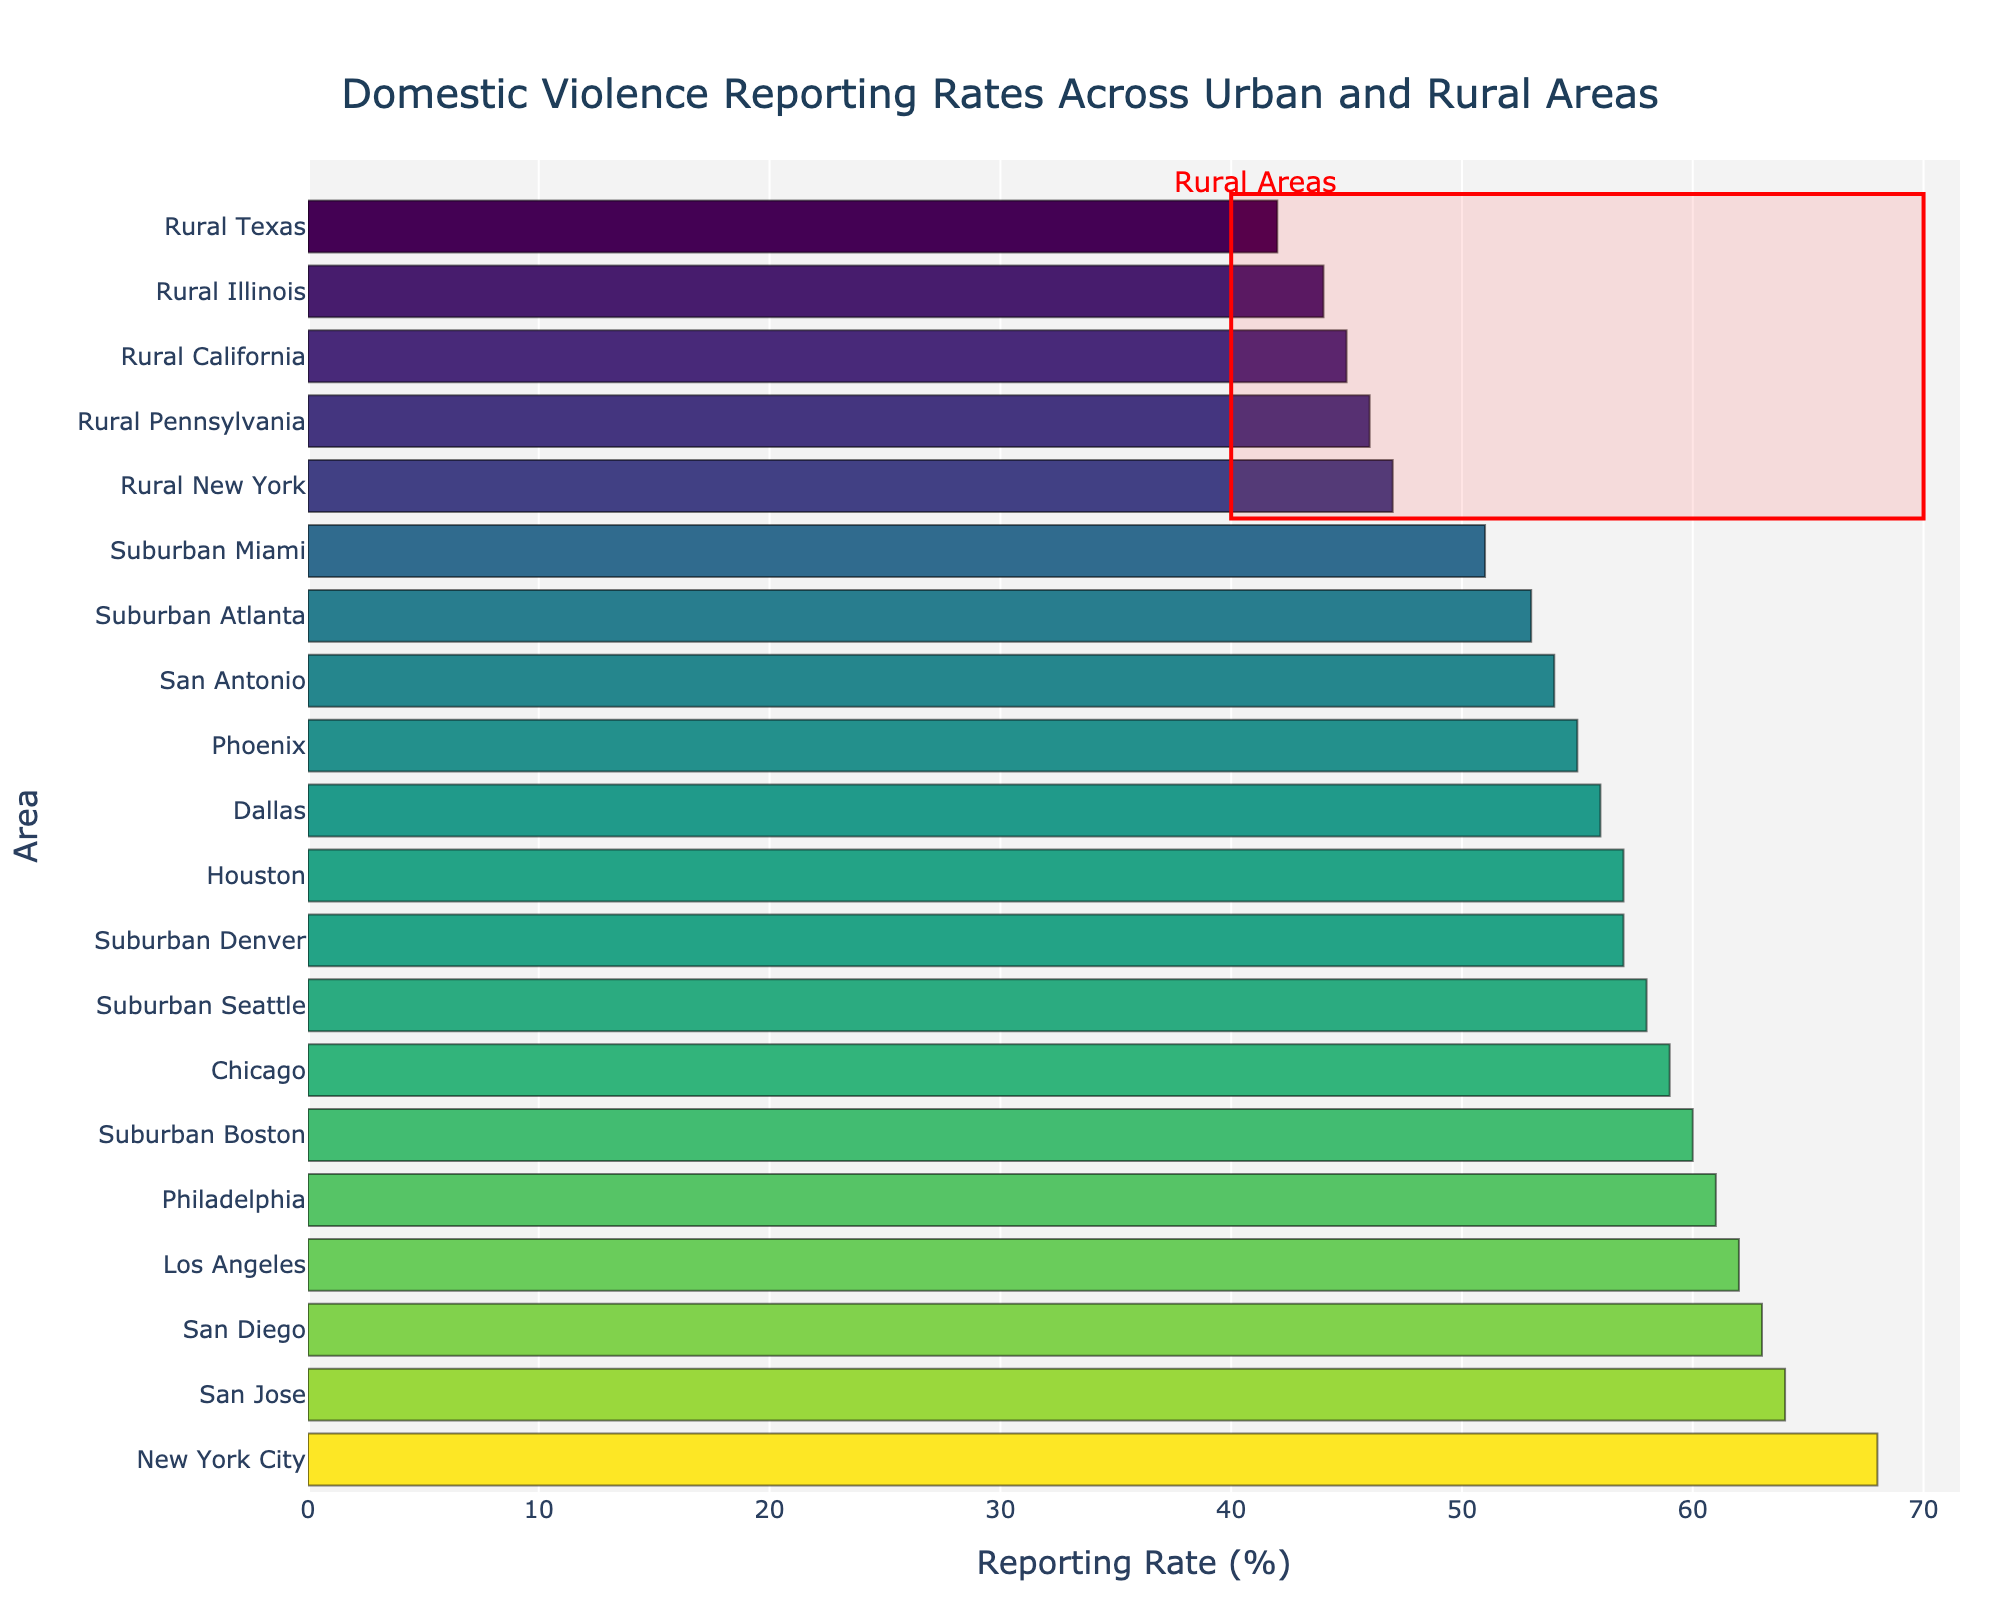What's the reporting rate for rural Texas? Look for the bar corresponding to Rural Texas and read its value from the X-axis.
Answer: 42 Which urban area has the highest reporting rate? Scan the bars corresponding to urban areas and identify the one with the highest reporting rate. This is New York City.
Answer: New York City What is the difference in reporting rate between the highest (New York City) and lowest (Rural Texas) areas? Identify the reporting rates for New York City (68%) and Rural Texas (42%) and subtract the lower value from the higher one: 68% - 42%.
Answer: 26 Is the reporting rate higher in Philadelphia or Dallas? Compare the bar heights for Philadelphia (61%) and Dallas (56%) to see which one is higher.
Answer: Philadelphia What is the average reporting rate of suburban areas shown? Sum the reporting rates of suburban areas (53 + 51 + 58 + 60 + 57). The total is 279. Divide by the number of suburban areas (5).
Answer: 55.8 Which rural area has the highest reporting rate? Among the rural areas (Rural Texas, Rural California, Rural New York, Rural Illinois, Rural Pennsylvania), find the one with the highest value. This is Rural New York with 47%.
Answer: Rural New York What color and section does the bar corresponding to Chicago belong to? Observe the color and group section where Chicago (59%) falls into. The color is part of the greenish hue in the Viridis colorscale.
Answer: Greenish hue How many areas have a reporting rate above 60%? Scan the chart to count the bars with reporting rates above 60%—New York City, Los Angeles, Philadelphia, San Diego, San Jose.
Answer: 5 Compare the reporting rates of Phoenix and Houston. Which one is higher and by how much? Identify the reporting rates for Phoenix (55%) and Houston (57%), then subtract the smaller from the larger rate: 57% - 55%.
Answer: Houston by 2% What is the median reporting rate among all areas? List all reporting rates in ascending order: (42, 44, 45, 46, 47, 51, 53, 54, 55, 56, 57, 57, 58, 59, 60, 61, 62, 63, 64, 68) and find the middle value. Since there are 20 values, the median is the average of the 10th and 11th values (55 + 56) / 2.
Answer: 55.5 